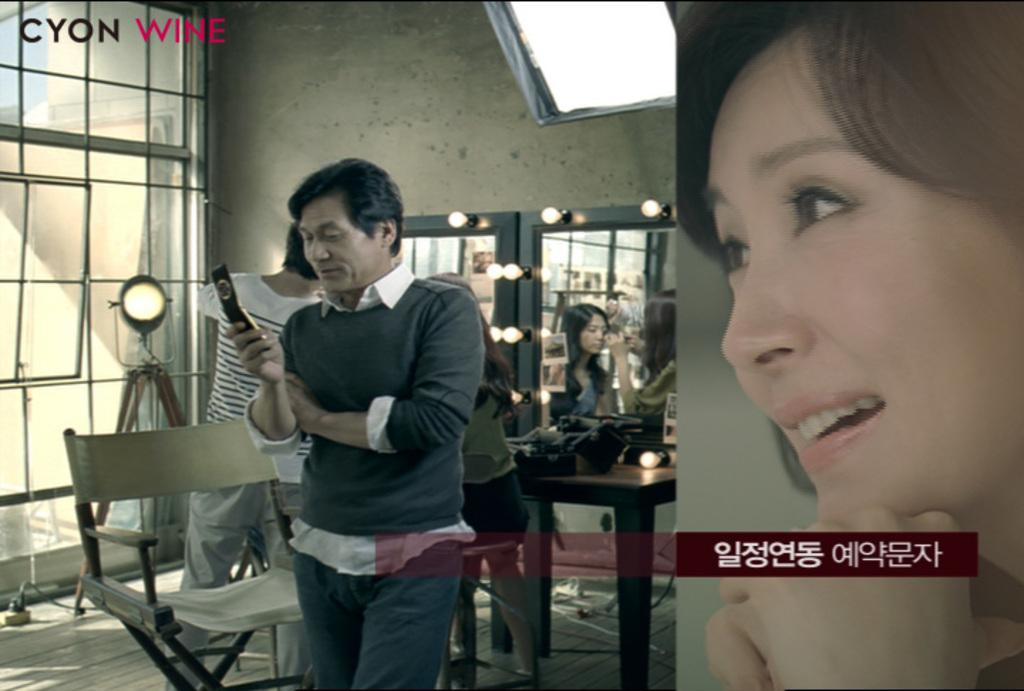What is the man in the image doing? The man is looking at a mobile phone in his hand. Can you describe the position of the second man in the image? There is another man behind the first man. What type of cheese is the man holding in the image? There is no cheese present in the image; the man is holding a mobile phone. 